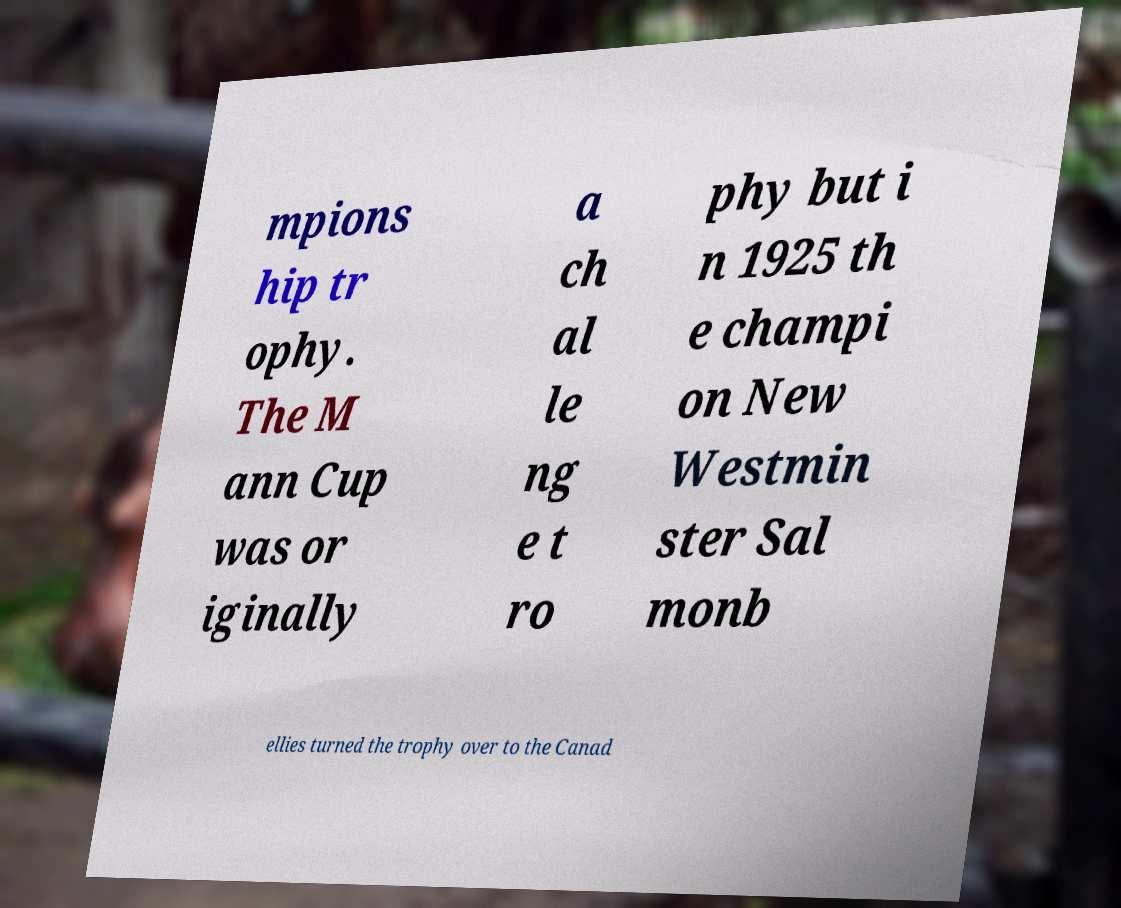Could you assist in decoding the text presented in this image and type it out clearly? mpions hip tr ophy. The M ann Cup was or iginally a ch al le ng e t ro phy but i n 1925 th e champi on New Westmin ster Sal monb ellies turned the trophy over to the Canad 